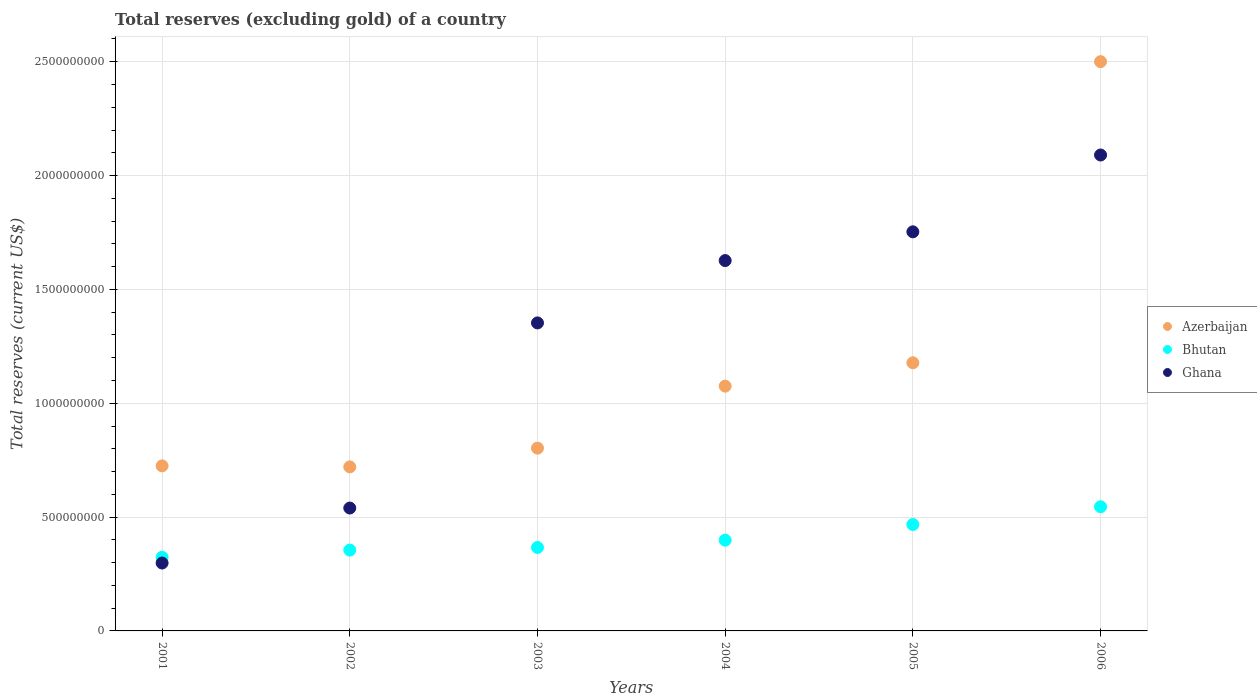Is the number of dotlines equal to the number of legend labels?
Your answer should be compact. Yes. What is the total reserves (excluding gold) in Azerbaijan in 2004?
Provide a succinct answer. 1.08e+09. Across all years, what is the maximum total reserves (excluding gold) in Azerbaijan?
Your answer should be very brief. 2.50e+09. Across all years, what is the minimum total reserves (excluding gold) in Azerbaijan?
Offer a terse response. 7.20e+08. In which year was the total reserves (excluding gold) in Azerbaijan maximum?
Offer a very short reply. 2006. In which year was the total reserves (excluding gold) in Ghana minimum?
Provide a succinct answer. 2001. What is the total total reserves (excluding gold) in Bhutan in the graph?
Your answer should be compact. 2.46e+09. What is the difference between the total reserves (excluding gold) in Ghana in 2002 and that in 2006?
Your answer should be very brief. -1.55e+09. What is the difference between the total reserves (excluding gold) in Bhutan in 2004 and the total reserves (excluding gold) in Ghana in 2005?
Give a very brief answer. -1.35e+09. What is the average total reserves (excluding gold) in Bhutan per year?
Your answer should be compact. 4.09e+08. In the year 2004, what is the difference between the total reserves (excluding gold) in Ghana and total reserves (excluding gold) in Bhutan?
Make the answer very short. 1.23e+09. In how many years, is the total reserves (excluding gold) in Azerbaijan greater than 2300000000 US$?
Provide a short and direct response. 1. What is the ratio of the total reserves (excluding gold) in Azerbaijan in 2003 to that in 2006?
Your response must be concise. 0.32. Is the total reserves (excluding gold) in Ghana in 2002 less than that in 2005?
Give a very brief answer. Yes. Is the difference between the total reserves (excluding gold) in Ghana in 2001 and 2004 greater than the difference between the total reserves (excluding gold) in Bhutan in 2001 and 2004?
Ensure brevity in your answer.  No. What is the difference between the highest and the second highest total reserves (excluding gold) in Ghana?
Your answer should be compact. 3.37e+08. What is the difference between the highest and the lowest total reserves (excluding gold) in Azerbaijan?
Your response must be concise. 1.78e+09. Is the sum of the total reserves (excluding gold) in Azerbaijan in 2005 and 2006 greater than the maximum total reserves (excluding gold) in Bhutan across all years?
Keep it short and to the point. Yes. Is it the case that in every year, the sum of the total reserves (excluding gold) in Bhutan and total reserves (excluding gold) in Azerbaijan  is greater than the total reserves (excluding gold) in Ghana?
Provide a short and direct response. No. Does the total reserves (excluding gold) in Azerbaijan monotonically increase over the years?
Make the answer very short. No. Are the values on the major ticks of Y-axis written in scientific E-notation?
Your response must be concise. No. Does the graph contain any zero values?
Ensure brevity in your answer.  No. Does the graph contain grids?
Give a very brief answer. Yes. How many legend labels are there?
Provide a succinct answer. 3. What is the title of the graph?
Offer a very short reply. Total reserves (excluding gold) of a country. Does "Iran" appear as one of the legend labels in the graph?
Offer a terse response. No. What is the label or title of the Y-axis?
Provide a succinct answer. Total reserves (current US$). What is the Total reserves (current US$) in Azerbaijan in 2001?
Your response must be concise. 7.25e+08. What is the Total reserves (current US$) of Bhutan in 2001?
Give a very brief answer. 3.23e+08. What is the Total reserves (current US$) in Ghana in 2001?
Offer a terse response. 2.98e+08. What is the Total reserves (current US$) in Azerbaijan in 2002?
Give a very brief answer. 7.20e+08. What is the Total reserves (current US$) of Bhutan in 2002?
Make the answer very short. 3.55e+08. What is the Total reserves (current US$) in Ghana in 2002?
Your answer should be very brief. 5.40e+08. What is the Total reserves (current US$) in Azerbaijan in 2003?
Your answer should be compact. 8.03e+08. What is the Total reserves (current US$) in Bhutan in 2003?
Ensure brevity in your answer.  3.67e+08. What is the Total reserves (current US$) in Ghana in 2003?
Give a very brief answer. 1.35e+09. What is the Total reserves (current US$) of Azerbaijan in 2004?
Offer a very short reply. 1.08e+09. What is the Total reserves (current US$) in Bhutan in 2004?
Provide a succinct answer. 3.99e+08. What is the Total reserves (current US$) in Ghana in 2004?
Provide a succinct answer. 1.63e+09. What is the Total reserves (current US$) of Azerbaijan in 2005?
Your answer should be compact. 1.18e+09. What is the Total reserves (current US$) of Bhutan in 2005?
Your answer should be very brief. 4.67e+08. What is the Total reserves (current US$) of Ghana in 2005?
Make the answer very short. 1.75e+09. What is the Total reserves (current US$) of Azerbaijan in 2006?
Make the answer very short. 2.50e+09. What is the Total reserves (current US$) of Bhutan in 2006?
Provide a succinct answer. 5.45e+08. What is the Total reserves (current US$) of Ghana in 2006?
Ensure brevity in your answer.  2.09e+09. Across all years, what is the maximum Total reserves (current US$) in Azerbaijan?
Ensure brevity in your answer.  2.50e+09. Across all years, what is the maximum Total reserves (current US$) of Bhutan?
Make the answer very short. 5.45e+08. Across all years, what is the maximum Total reserves (current US$) in Ghana?
Make the answer very short. 2.09e+09. Across all years, what is the minimum Total reserves (current US$) of Azerbaijan?
Keep it short and to the point. 7.20e+08. Across all years, what is the minimum Total reserves (current US$) of Bhutan?
Make the answer very short. 3.23e+08. Across all years, what is the minimum Total reserves (current US$) in Ghana?
Provide a short and direct response. 2.98e+08. What is the total Total reserves (current US$) in Azerbaijan in the graph?
Keep it short and to the point. 7.00e+09. What is the total Total reserves (current US$) of Bhutan in the graph?
Provide a succinct answer. 2.46e+09. What is the total Total reserves (current US$) of Ghana in the graph?
Your response must be concise. 7.66e+09. What is the difference between the Total reserves (current US$) of Azerbaijan in 2001 and that in 2002?
Offer a very short reply. 4.51e+06. What is the difference between the Total reserves (current US$) of Bhutan in 2001 and that in 2002?
Offer a terse response. -3.16e+07. What is the difference between the Total reserves (current US$) in Ghana in 2001 and that in 2002?
Provide a succinct answer. -2.42e+08. What is the difference between the Total reserves (current US$) in Azerbaijan in 2001 and that in 2003?
Offer a very short reply. -7.79e+07. What is the difference between the Total reserves (current US$) in Bhutan in 2001 and that in 2003?
Your answer should be very brief. -4.32e+07. What is the difference between the Total reserves (current US$) in Ghana in 2001 and that in 2003?
Your answer should be compact. -1.05e+09. What is the difference between the Total reserves (current US$) of Azerbaijan in 2001 and that in 2004?
Your response must be concise. -3.50e+08. What is the difference between the Total reserves (current US$) in Bhutan in 2001 and that in 2004?
Give a very brief answer. -7.53e+07. What is the difference between the Total reserves (current US$) in Ghana in 2001 and that in 2004?
Provide a short and direct response. -1.33e+09. What is the difference between the Total reserves (current US$) of Azerbaijan in 2001 and that in 2005?
Keep it short and to the point. -4.53e+08. What is the difference between the Total reserves (current US$) in Bhutan in 2001 and that in 2005?
Offer a very short reply. -1.44e+08. What is the difference between the Total reserves (current US$) of Ghana in 2001 and that in 2005?
Your response must be concise. -1.45e+09. What is the difference between the Total reserves (current US$) of Azerbaijan in 2001 and that in 2006?
Offer a very short reply. -1.78e+09. What is the difference between the Total reserves (current US$) in Bhutan in 2001 and that in 2006?
Your response must be concise. -2.22e+08. What is the difference between the Total reserves (current US$) in Ghana in 2001 and that in 2006?
Provide a short and direct response. -1.79e+09. What is the difference between the Total reserves (current US$) of Azerbaijan in 2002 and that in 2003?
Keep it short and to the point. -8.24e+07. What is the difference between the Total reserves (current US$) in Bhutan in 2002 and that in 2003?
Offer a terse response. -1.16e+07. What is the difference between the Total reserves (current US$) in Ghana in 2002 and that in 2003?
Make the answer very short. -8.13e+08. What is the difference between the Total reserves (current US$) of Azerbaijan in 2002 and that in 2004?
Make the answer very short. -3.55e+08. What is the difference between the Total reserves (current US$) in Bhutan in 2002 and that in 2004?
Provide a succinct answer. -4.37e+07. What is the difference between the Total reserves (current US$) of Ghana in 2002 and that in 2004?
Ensure brevity in your answer.  -1.09e+09. What is the difference between the Total reserves (current US$) of Azerbaijan in 2002 and that in 2005?
Your answer should be very brief. -4.57e+08. What is the difference between the Total reserves (current US$) in Bhutan in 2002 and that in 2005?
Provide a succinct answer. -1.12e+08. What is the difference between the Total reserves (current US$) in Ghana in 2002 and that in 2005?
Provide a short and direct response. -1.21e+09. What is the difference between the Total reserves (current US$) of Azerbaijan in 2002 and that in 2006?
Your answer should be very brief. -1.78e+09. What is the difference between the Total reserves (current US$) in Bhutan in 2002 and that in 2006?
Provide a succinct answer. -1.90e+08. What is the difference between the Total reserves (current US$) of Ghana in 2002 and that in 2006?
Provide a succinct answer. -1.55e+09. What is the difference between the Total reserves (current US$) in Azerbaijan in 2003 and that in 2004?
Keep it short and to the point. -2.72e+08. What is the difference between the Total reserves (current US$) in Bhutan in 2003 and that in 2004?
Give a very brief answer. -3.20e+07. What is the difference between the Total reserves (current US$) of Ghana in 2003 and that in 2004?
Offer a terse response. -2.74e+08. What is the difference between the Total reserves (current US$) in Azerbaijan in 2003 and that in 2005?
Make the answer very short. -3.75e+08. What is the difference between the Total reserves (current US$) in Bhutan in 2003 and that in 2005?
Give a very brief answer. -1.01e+08. What is the difference between the Total reserves (current US$) in Ghana in 2003 and that in 2005?
Your answer should be very brief. -4.00e+08. What is the difference between the Total reserves (current US$) of Azerbaijan in 2003 and that in 2006?
Offer a terse response. -1.70e+09. What is the difference between the Total reserves (current US$) of Bhutan in 2003 and that in 2006?
Offer a terse response. -1.79e+08. What is the difference between the Total reserves (current US$) in Ghana in 2003 and that in 2006?
Keep it short and to the point. -7.37e+08. What is the difference between the Total reserves (current US$) of Azerbaijan in 2004 and that in 2005?
Keep it short and to the point. -1.03e+08. What is the difference between the Total reserves (current US$) in Bhutan in 2004 and that in 2005?
Provide a short and direct response. -6.88e+07. What is the difference between the Total reserves (current US$) in Ghana in 2004 and that in 2005?
Keep it short and to the point. -1.26e+08. What is the difference between the Total reserves (current US$) of Azerbaijan in 2004 and that in 2006?
Keep it short and to the point. -1.43e+09. What is the difference between the Total reserves (current US$) of Bhutan in 2004 and that in 2006?
Your response must be concise. -1.47e+08. What is the difference between the Total reserves (current US$) in Ghana in 2004 and that in 2006?
Offer a very short reply. -4.64e+08. What is the difference between the Total reserves (current US$) of Azerbaijan in 2005 and that in 2006?
Offer a terse response. -1.32e+09. What is the difference between the Total reserves (current US$) in Bhutan in 2005 and that in 2006?
Provide a succinct answer. -7.79e+07. What is the difference between the Total reserves (current US$) of Ghana in 2005 and that in 2006?
Provide a succinct answer. -3.37e+08. What is the difference between the Total reserves (current US$) of Azerbaijan in 2001 and the Total reserves (current US$) of Bhutan in 2002?
Make the answer very short. 3.70e+08. What is the difference between the Total reserves (current US$) of Azerbaijan in 2001 and the Total reserves (current US$) of Ghana in 2002?
Your answer should be very brief. 1.85e+08. What is the difference between the Total reserves (current US$) of Bhutan in 2001 and the Total reserves (current US$) of Ghana in 2002?
Ensure brevity in your answer.  -2.16e+08. What is the difference between the Total reserves (current US$) of Azerbaijan in 2001 and the Total reserves (current US$) of Bhutan in 2003?
Offer a terse response. 3.58e+08. What is the difference between the Total reserves (current US$) of Azerbaijan in 2001 and the Total reserves (current US$) of Ghana in 2003?
Offer a very short reply. -6.28e+08. What is the difference between the Total reserves (current US$) of Bhutan in 2001 and the Total reserves (current US$) of Ghana in 2003?
Offer a terse response. -1.03e+09. What is the difference between the Total reserves (current US$) in Azerbaijan in 2001 and the Total reserves (current US$) in Bhutan in 2004?
Your answer should be very brief. 3.26e+08. What is the difference between the Total reserves (current US$) of Azerbaijan in 2001 and the Total reserves (current US$) of Ghana in 2004?
Keep it short and to the point. -9.02e+08. What is the difference between the Total reserves (current US$) in Bhutan in 2001 and the Total reserves (current US$) in Ghana in 2004?
Keep it short and to the point. -1.30e+09. What is the difference between the Total reserves (current US$) of Azerbaijan in 2001 and the Total reserves (current US$) of Bhutan in 2005?
Provide a succinct answer. 2.58e+08. What is the difference between the Total reserves (current US$) of Azerbaijan in 2001 and the Total reserves (current US$) of Ghana in 2005?
Keep it short and to the point. -1.03e+09. What is the difference between the Total reserves (current US$) of Bhutan in 2001 and the Total reserves (current US$) of Ghana in 2005?
Make the answer very short. -1.43e+09. What is the difference between the Total reserves (current US$) in Azerbaijan in 2001 and the Total reserves (current US$) in Bhutan in 2006?
Offer a terse response. 1.80e+08. What is the difference between the Total reserves (current US$) of Azerbaijan in 2001 and the Total reserves (current US$) of Ghana in 2006?
Make the answer very short. -1.37e+09. What is the difference between the Total reserves (current US$) of Bhutan in 2001 and the Total reserves (current US$) of Ghana in 2006?
Your answer should be compact. -1.77e+09. What is the difference between the Total reserves (current US$) of Azerbaijan in 2002 and the Total reserves (current US$) of Bhutan in 2003?
Give a very brief answer. 3.54e+08. What is the difference between the Total reserves (current US$) in Azerbaijan in 2002 and the Total reserves (current US$) in Ghana in 2003?
Your response must be concise. -6.32e+08. What is the difference between the Total reserves (current US$) in Bhutan in 2002 and the Total reserves (current US$) in Ghana in 2003?
Give a very brief answer. -9.98e+08. What is the difference between the Total reserves (current US$) in Azerbaijan in 2002 and the Total reserves (current US$) in Bhutan in 2004?
Offer a very short reply. 3.22e+08. What is the difference between the Total reserves (current US$) of Azerbaijan in 2002 and the Total reserves (current US$) of Ghana in 2004?
Provide a short and direct response. -9.06e+08. What is the difference between the Total reserves (current US$) of Bhutan in 2002 and the Total reserves (current US$) of Ghana in 2004?
Ensure brevity in your answer.  -1.27e+09. What is the difference between the Total reserves (current US$) of Azerbaijan in 2002 and the Total reserves (current US$) of Bhutan in 2005?
Your answer should be very brief. 2.53e+08. What is the difference between the Total reserves (current US$) of Azerbaijan in 2002 and the Total reserves (current US$) of Ghana in 2005?
Your response must be concise. -1.03e+09. What is the difference between the Total reserves (current US$) of Bhutan in 2002 and the Total reserves (current US$) of Ghana in 2005?
Ensure brevity in your answer.  -1.40e+09. What is the difference between the Total reserves (current US$) in Azerbaijan in 2002 and the Total reserves (current US$) in Bhutan in 2006?
Your response must be concise. 1.75e+08. What is the difference between the Total reserves (current US$) of Azerbaijan in 2002 and the Total reserves (current US$) of Ghana in 2006?
Your answer should be compact. -1.37e+09. What is the difference between the Total reserves (current US$) in Bhutan in 2002 and the Total reserves (current US$) in Ghana in 2006?
Provide a succinct answer. -1.74e+09. What is the difference between the Total reserves (current US$) in Azerbaijan in 2003 and the Total reserves (current US$) in Bhutan in 2004?
Provide a succinct answer. 4.04e+08. What is the difference between the Total reserves (current US$) in Azerbaijan in 2003 and the Total reserves (current US$) in Ghana in 2004?
Keep it short and to the point. -8.24e+08. What is the difference between the Total reserves (current US$) of Bhutan in 2003 and the Total reserves (current US$) of Ghana in 2004?
Offer a terse response. -1.26e+09. What is the difference between the Total reserves (current US$) in Azerbaijan in 2003 and the Total reserves (current US$) in Bhutan in 2005?
Your answer should be very brief. 3.35e+08. What is the difference between the Total reserves (current US$) of Azerbaijan in 2003 and the Total reserves (current US$) of Ghana in 2005?
Your response must be concise. -9.50e+08. What is the difference between the Total reserves (current US$) in Bhutan in 2003 and the Total reserves (current US$) in Ghana in 2005?
Your answer should be compact. -1.39e+09. What is the difference between the Total reserves (current US$) in Azerbaijan in 2003 and the Total reserves (current US$) in Bhutan in 2006?
Ensure brevity in your answer.  2.58e+08. What is the difference between the Total reserves (current US$) in Azerbaijan in 2003 and the Total reserves (current US$) in Ghana in 2006?
Make the answer very short. -1.29e+09. What is the difference between the Total reserves (current US$) of Bhutan in 2003 and the Total reserves (current US$) of Ghana in 2006?
Give a very brief answer. -1.72e+09. What is the difference between the Total reserves (current US$) in Azerbaijan in 2004 and the Total reserves (current US$) in Bhutan in 2005?
Keep it short and to the point. 6.08e+08. What is the difference between the Total reserves (current US$) in Azerbaijan in 2004 and the Total reserves (current US$) in Ghana in 2005?
Offer a terse response. -6.78e+08. What is the difference between the Total reserves (current US$) in Bhutan in 2004 and the Total reserves (current US$) in Ghana in 2005?
Make the answer very short. -1.35e+09. What is the difference between the Total reserves (current US$) of Azerbaijan in 2004 and the Total reserves (current US$) of Bhutan in 2006?
Offer a terse response. 5.30e+08. What is the difference between the Total reserves (current US$) in Azerbaijan in 2004 and the Total reserves (current US$) in Ghana in 2006?
Your response must be concise. -1.02e+09. What is the difference between the Total reserves (current US$) in Bhutan in 2004 and the Total reserves (current US$) in Ghana in 2006?
Your answer should be compact. -1.69e+09. What is the difference between the Total reserves (current US$) in Azerbaijan in 2005 and the Total reserves (current US$) in Bhutan in 2006?
Your response must be concise. 6.32e+08. What is the difference between the Total reserves (current US$) in Azerbaijan in 2005 and the Total reserves (current US$) in Ghana in 2006?
Your answer should be very brief. -9.13e+08. What is the difference between the Total reserves (current US$) of Bhutan in 2005 and the Total reserves (current US$) of Ghana in 2006?
Offer a terse response. -1.62e+09. What is the average Total reserves (current US$) of Azerbaijan per year?
Your response must be concise. 1.17e+09. What is the average Total reserves (current US$) of Bhutan per year?
Ensure brevity in your answer.  4.09e+08. What is the average Total reserves (current US$) in Ghana per year?
Offer a terse response. 1.28e+09. In the year 2001, what is the difference between the Total reserves (current US$) in Azerbaijan and Total reserves (current US$) in Bhutan?
Offer a terse response. 4.02e+08. In the year 2001, what is the difference between the Total reserves (current US$) in Azerbaijan and Total reserves (current US$) in Ghana?
Keep it short and to the point. 4.27e+08. In the year 2001, what is the difference between the Total reserves (current US$) of Bhutan and Total reserves (current US$) of Ghana?
Offer a very short reply. 2.51e+07. In the year 2002, what is the difference between the Total reserves (current US$) in Azerbaijan and Total reserves (current US$) in Bhutan?
Your answer should be compact. 3.66e+08. In the year 2002, what is the difference between the Total reserves (current US$) of Azerbaijan and Total reserves (current US$) of Ghana?
Offer a terse response. 1.81e+08. In the year 2002, what is the difference between the Total reserves (current US$) in Bhutan and Total reserves (current US$) in Ghana?
Your response must be concise. -1.85e+08. In the year 2003, what is the difference between the Total reserves (current US$) of Azerbaijan and Total reserves (current US$) of Bhutan?
Give a very brief answer. 4.36e+08. In the year 2003, what is the difference between the Total reserves (current US$) of Azerbaijan and Total reserves (current US$) of Ghana?
Your response must be concise. -5.50e+08. In the year 2003, what is the difference between the Total reserves (current US$) in Bhutan and Total reserves (current US$) in Ghana?
Offer a very short reply. -9.86e+08. In the year 2004, what is the difference between the Total reserves (current US$) of Azerbaijan and Total reserves (current US$) of Bhutan?
Keep it short and to the point. 6.76e+08. In the year 2004, what is the difference between the Total reserves (current US$) of Azerbaijan and Total reserves (current US$) of Ghana?
Offer a terse response. -5.52e+08. In the year 2004, what is the difference between the Total reserves (current US$) in Bhutan and Total reserves (current US$) in Ghana?
Give a very brief answer. -1.23e+09. In the year 2005, what is the difference between the Total reserves (current US$) in Azerbaijan and Total reserves (current US$) in Bhutan?
Your answer should be very brief. 7.10e+08. In the year 2005, what is the difference between the Total reserves (current US$) of Azerbaijan and Total reserves (current US$) of Ghana?
Your answer should be compact. -5.75e+08. In the year 2005, what is the difference between the Total reserves (current US$) in Bhutan and Total reserves (current US$) in Ghana?
Offer a very short reply. -1.29e+09. In the year 2006, what is the difference between the Total reserves (current US$) in Azerbaijan and Total reserves (current US$) in Bhutan?
Give a very brief answer. 1.96e+09. In the year 2006, what is the difference between the Total reserves (current US$) in Azerbaijan and Total reserves (current US$) in Ghana?
Ensure brevity in your answer.  4.10e+08. In the year 2006, what is the difference between the Total reserves (current US$) in Bhutan and Total reserves (current US$) in Ghana?
Make the answer very short. -1.54e+09. What is the ratio of the Total reserves (current US$) of Azerbaijan in 2001 to that in 2002?
Provide a short and direct response. 1.01. What is the ratio of the Total reserves (current US$) of Bhutan in 2001 to that in 2002?
Keep it short and to the point. 0.91. What is the ratio of the Total reserves (current US$) of Ghana in 2001 to that in 2002?
Provide a succinct answer. 0.55. What is the ratio of the Total reserves (current US$) of Azerbaijan in 2001 to that in 2003?
Offer a very short reply. 0.9. What is the ratio of the Total reserves (current US$) in Bhutan in 2001 to that in 2003?
Give a very brief answer. 0.88. What is the ratio of the Total reserves (current US$) in Ghana in 2001 to that in 2003?
Give a very brief answer. 0.22. What is the ratio of the Total reserves (current US$) of Azerbaijan in 2001 to that in 2004?
Offer a terse response. 0.67. What is the ratio of the Total reserves (current US$) in Bhutan in 2001 to that in 2004?
Offer a terse response. 0.81. What is the ratio of the Total reserves (current US$) of Ghana in 2001 to that in 2004?
Your response must be concise. 0.18. What is the ratio of the Total reserves (current US$) in Azerbaijan in 2001 to that in 2005?
Your response must be concise. 0.62. What is the ratio of the Total reserves (current US$) in Bhutan in 2001 to that in 2005?
Provide a short and direct response. 0.69. What is the ratio of the Total reserves (current US$) in Ghana in 2001 to that in 2005?
Provide a succinct answer. 0.17. What is the ratio of the Total reserves (current US$) in Azerbaijan in 2001 to that in 2006?
Your answer should be very brief. 0.29. What is the ratio of the Total reserves (current US$) of Bhutan in 2001 to that in 2006?
Provide a short and direct response. 0.59. What is the ratio of the Total reserves (current US$) in Ghana in 2001 to that in 2006?
Your answer should be very brief. 0.14. What is the ratio of the Total reserves (current US$) in Azerbaijan in 2002 to that in 2003?
Your answer should be compact. 0.9. What is the ratio of the Total reserves (current US$) of Bhutan in 2002 to that in 2003?
Provide a succinct answer. 0.97. What is the ratio of the Total reserves (current US$) of Ghana in 2002 to that in 2003?
Offer a terse response. 0.4. What is the ratio of the Total reserves (current US$) of Azerbaijan in 2002 to that in 2004?
Your answer should be compact. 0.67. What is the ratio of the Total reserves (current US$) of Bhutan in 2002 to that in 2004?
Your answer should be compact. 0.89. What is the ratio of the Total reserves (current US$) of Ghana in 2002 to that in 2004?
Your response must be concise. 0.33. What is the ratio of the Total reserves (current US$) in Azerbaijan in 2002 to that in 2005?
Keep it short and to the point. 0.61. What is the ratio of the Total reserves (current US$) of Bhutan in 2002 to that in 2005?
Offer a very short reply. 0.76. What is the ratio of the Total reserves (current US$) of Ghana in 2002 to that in 2005?
Ensure brevity in your answer.  0.31. What is the ratio of the Total reserves (current US$) of Azerbaijan in 2002 to that in 2006?
Give a very brief answer. 0.29. What is the ratio of the Total reserves (current US$) in Bhutan in 2002 to that in 2006?
Offer a very short reply. 0.65. What is the ratio of the Total reserves (current US$) in Ghana in 2002 to that in 2006?
Offer a very short reply. 0.26. What is the ratio of the Total reserves (current US$) of Azerbaijan in 2003 to that in 2004?
Your answer should be very brief. 0.75. What is the ratio of the Total reserves (current US$) of Bhutan in 2003 to that in 2004?
Your response must be concise. 0.92. What is the ratio of the Total reserves (current US$) of Ghana in 2003 to that in 2004?
Offer a terse response. 0.83. What is the ratio of the Total reserves (current US$) in Azerbaijan in 2003 to that in 2005?
Ensure brevity in your answer.  0.68. What is the ratio of the Total reserves (current US$) of Bhutan in 2003 to that in 2005?
Offer a terse response. 0.78. What is the ratio of the Total reserves (current US$) of Ghana in 2003 to that in 2005?
Provide a succinct answer. 0.77. What is the ratio of the Total reserves (current US$) of Azerbaijan in 2003 to that in 2006?
Ensure brevity in your answer.  0.32. What is the ratio of the Total reserves (current US$) of Bhutan in 2003 to that in 2006?
Offer a very short reply. 0.67. What is the ratio of the Total reserves (current US$) of Ghana in 2003 to that in 2006?
Give a very brief answer. 0.65. What is the ratio of the Total reserves (current US$) of Azerbaijan in 2004 to that in 2005?
Offer a very short reply. 0.91. What is the ratio of the Total reserves (current US$) in Bhutan in 2004 to that in 2005?
Provide a short and direct response. 0.85. What is the ratio of the Total reserves (current US$) in Ghana in 2004 to that in 2005?
Your response must be concise. 0.93. What is the ratio of the Total reserves (current US$) in Azerbaijan in 2004 to that in 2006?
Your answer should be very brief. 0.43. What is the ratio of the Total reserves (current US$) of Bhutan in 2004 to that in 2006?
Provide a succinct answer. 0.73. What is the ratio of the Total reserves (current US$) of Ghana in 2004 to that in 2006?
Your answer should be very brief. 0.78. What is the ratio of the Total reserves (current US$) of Azerbaijan in 2005 to that in 2006?
Offer a very short reply. 0.47. What is the ratio of the Total reserves (current US$) in Bhutan in 2005 to that in 2006?
Offer a very short reply. 0.86. What is the ratio of the Total reserves (current US$) of Ghana in 2005 to that in 2006?
Offer a terse response. 0.84. What is the difference between the highest and the second highest Total reserves (current US$) of Azerbaijan?
Your response must be concise. 1.32e+09. What is the difference between the highest and the second highest Total reserves (current US$) in Bhutan?
Provide a succinct answer. 7.79e+07. What is the difference between the highest and the second highest Total reserves (current US$) of Ghana?
Make the answer very short. 3.37e+08. What is the difference between the highest and the lowest Total reserves (current US$) of Azerbaijan?
Offer a very short reply. 1.78e+09. What is the difference between the highest and the lowest Total reserves (current US$) in Bhutan?
Offer a very short reply. 2.22e+08. What is the difference between the highest and the lowest Total reserves (current US$) in Ghana?
Give a very brief answer. 1.79e+09. 